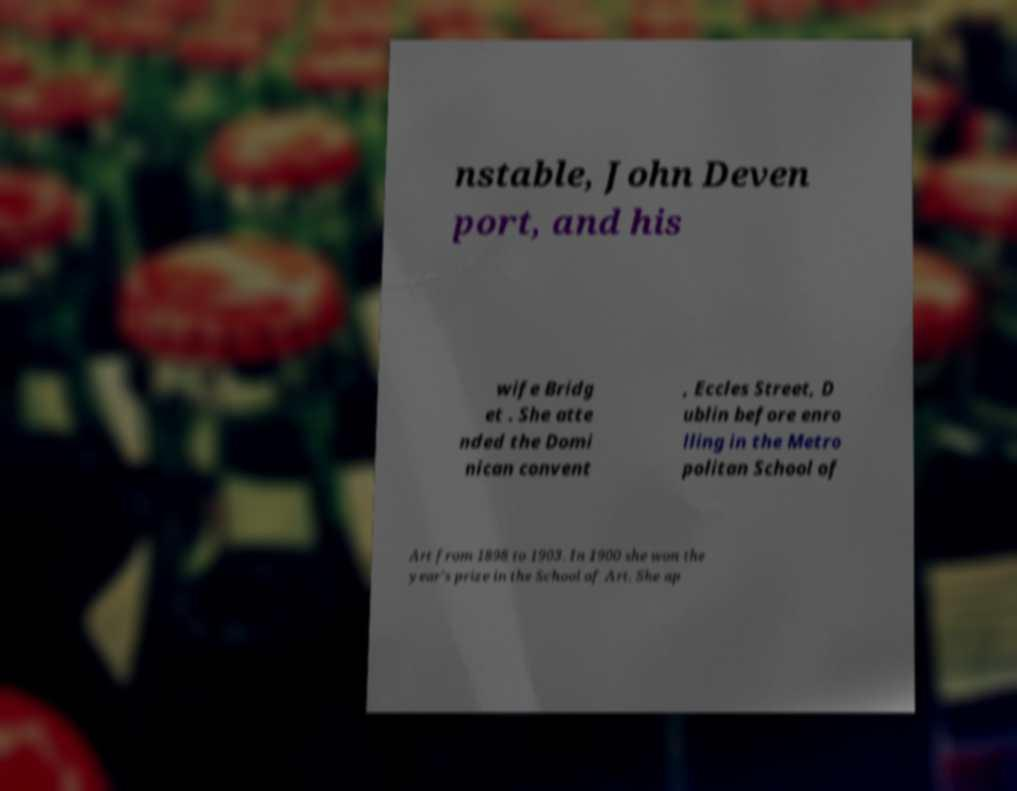Can you accurately transcribe the text from the provided image for me? nstable, John Deven port, and his wife Bridg et . She atte nded the Domi nican convent , Eccles Street, D ublin before enro lling in the Metro politan School of Art from 1898 to 1903. In 1900 she won the year's prize in the School of Art. She ap 